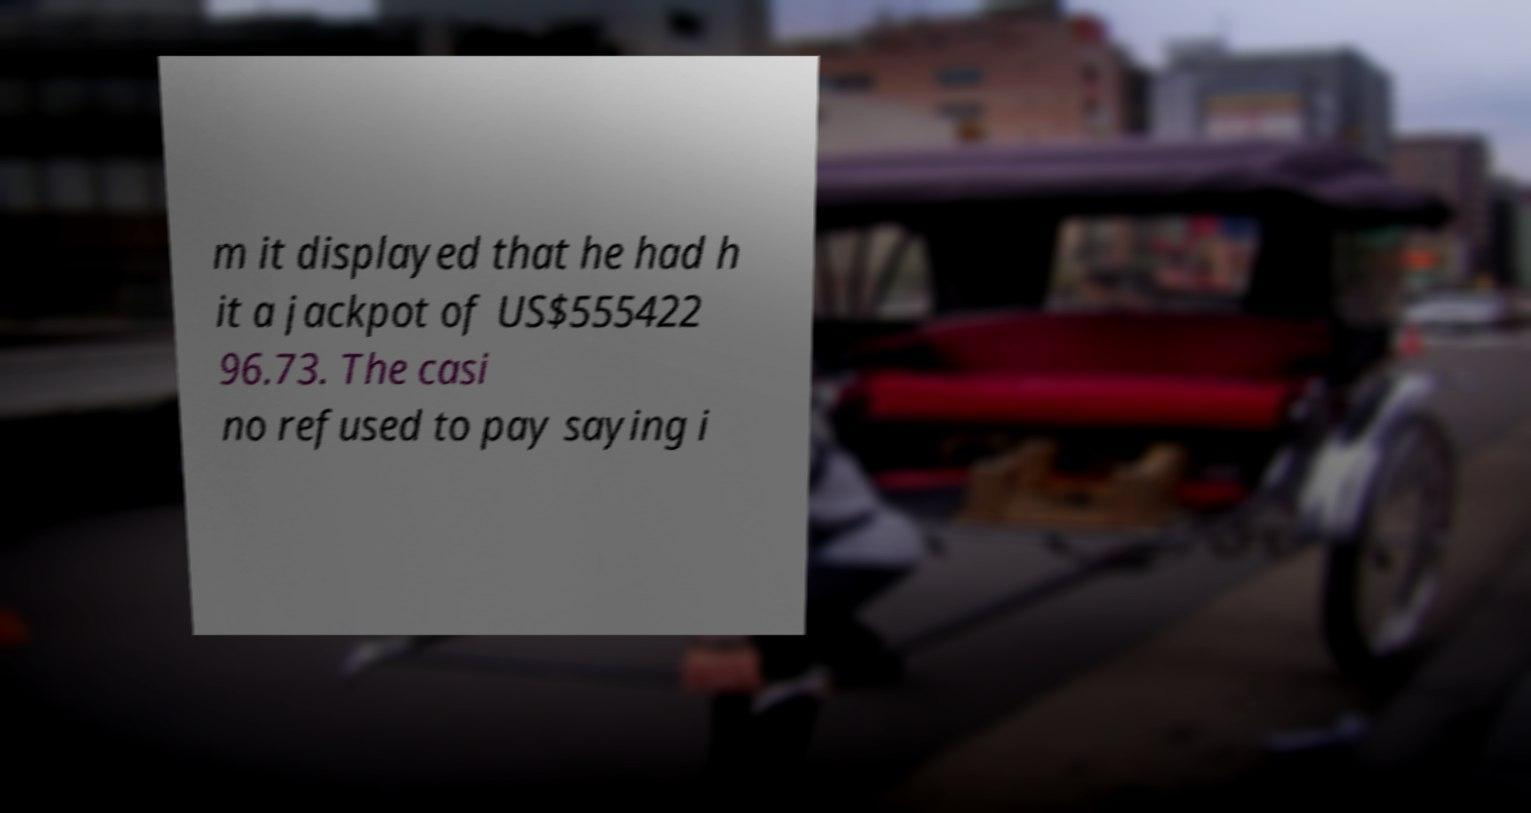Could you assist in decoding the text presented in this image and type it out clearly? m it displayed that he had h it a jackpot of US$555422 96.73. The casi no refused to pay saying i 